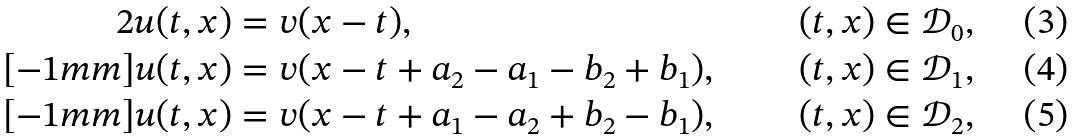Convert formula to latex. <formula><loc_0><loc_0><loc_500><loc_500>{ 2 } u ( t , x ) & = v ( x - t ) , & \quad ( t , x ) & \in \mathcal { D } _ { 0 } , \\ [ - 1 m m ] u ( t , x ) & = v ( x - t + a _ { 2 } - a _ { 1 } - b _ { 2 } + b _ { 1 } ) , & \quad ( t , x ) & \in \mathcal { D } _ { 1 } , \\ [ - 1 m m ] u ( t , x ) & = v ( x - t + a _ { 1 } - a _ { 2 } + b _ { 2 } - b _ { 1 } ) , & \quad ( t , x ) & \in \mathcal { D } _ { 2 } ,</formula> 